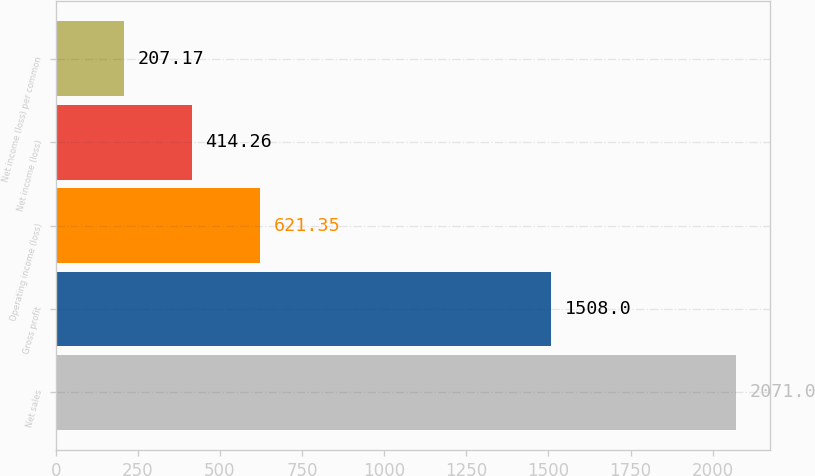Convert chart to OTSL. <chart><loc_0><loc_0><loc_500><loc_500><bar_chart><fcel>Net sales<fcel>Gross profit<fcel>Operating income (loss)<fcel>Net income (loss)<fcel>Net income (loss) per common<nl><fcel>2071<fcel>1508<fcel>621.35<fcel>414.26<fcel>207.17<nl></chart> 